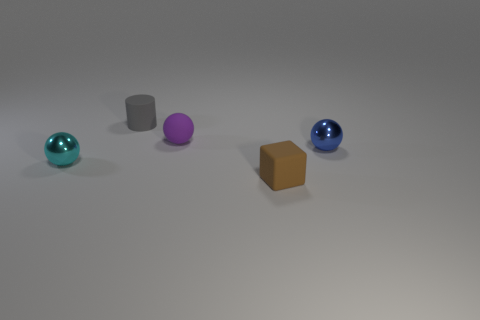Subtract all tiny metal balls. How many balls are left? 1 Add 3 small red things. How many objects exist? 8 Subtract all spheres. How many objects are left? 2 Subtract 0 cyan blocks. How many objects are left? 5 Subtract all small green rubber balls. Subtract all small brown cubes. How many objects are left? 4 Add 5 matte balls. How many matte balls are left? 6 Add 5 big red spheres. How many big red spheres exist? 5 